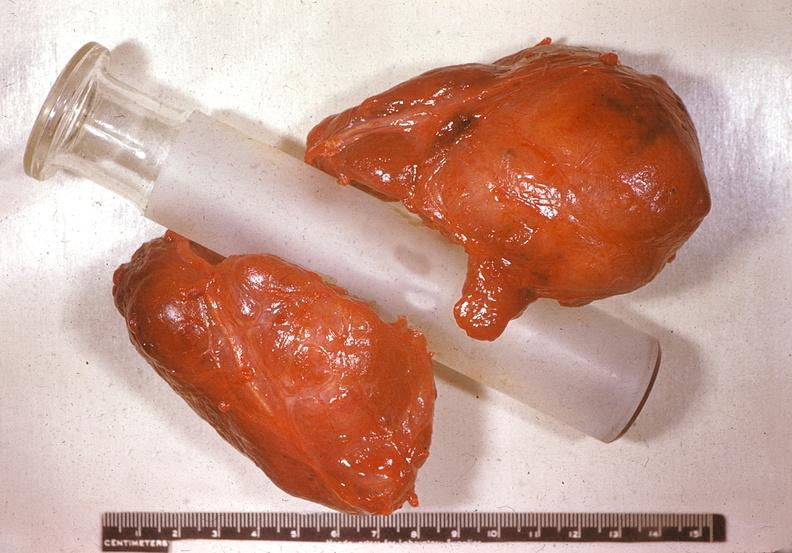does this image show thyroid, nodular colloid goiter?
Answer the question using a single word or phrase. Yes 